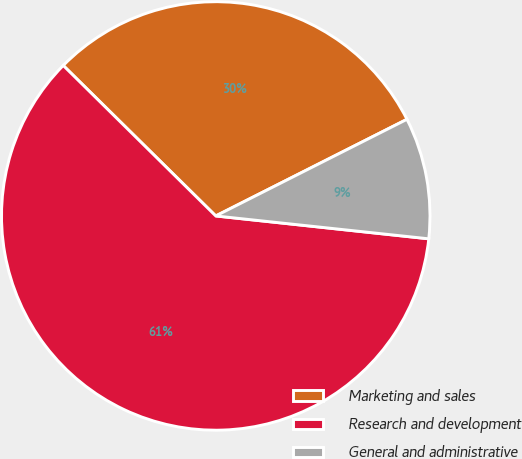Convert chart. <chart><loc_0><loc_0><loc_500><loc_500><pie_chart><fcel>Marketing and sales<fcel>Research and development<fcel>General and administrative<nl><fcel>30.16%<fcel>60.69%<fcel>9.15%<nl></chart> 